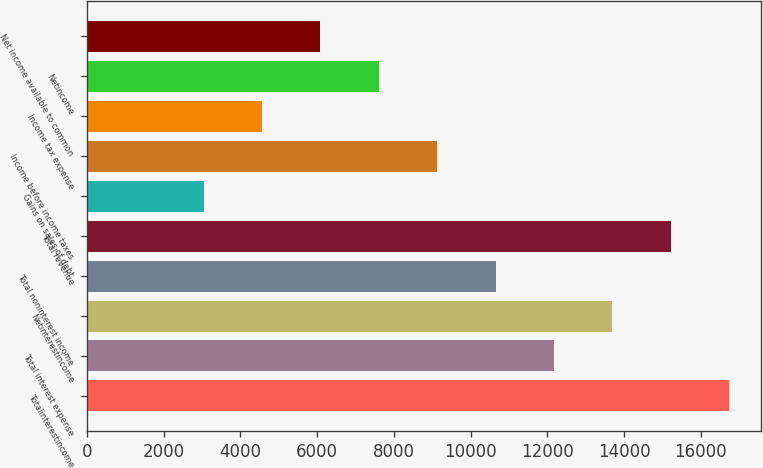<chart> <loc_0><loc_0><loc_500><loc_500><bar_chart><fcel>Totalinterestincome<fcel>Total interest expense<fcel>Netinterestincome<fcel>Total noninterest income<fcel>Total revenue<fcel>Gains on sales of debt<fcel>Income before income taxes<fcel>Income tax expense<fcel>Netincome<fcel>Net income available to common<nl><fcel>16744.1<fcel>12177.8<fcel>13699.9<fcel>10655.7<fcel>15222<fcel>3045.22<fcel>9133.62<fcel>4567.32<fcel>7611.52<fcel>6089.42<nl></chart> 